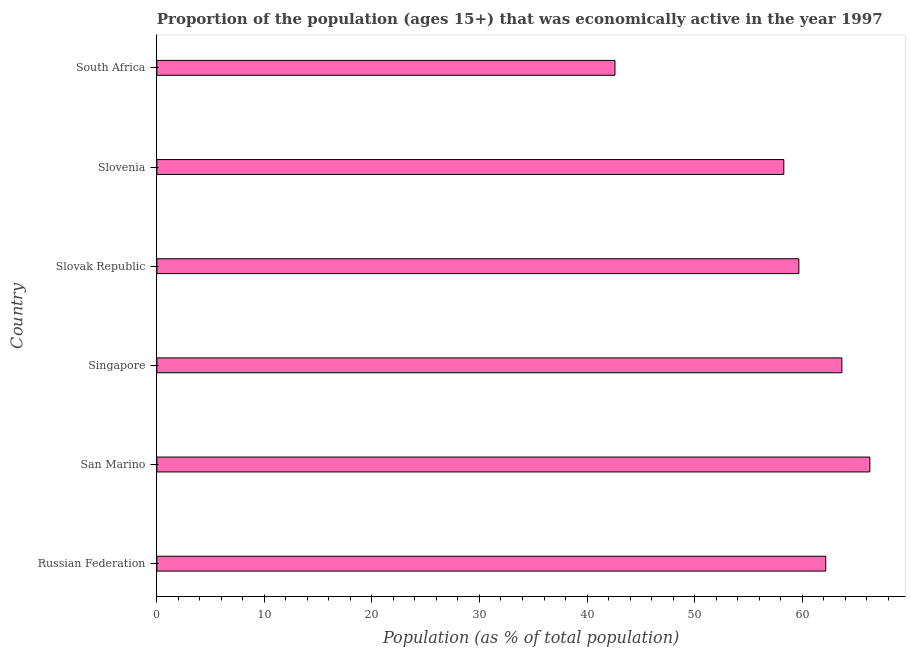What is the title of the graph?
Give a very brief answer. Proportion of the population (ages 15+) that was economically active in the year 1997. What is the label or title of the X-axis?
Keep it short and to the point. Population (as % of total population). What is the label or title of the Y-axis?
Offer a very short reply. Country. What is the percentage of economically active population in Singapore?
Your answer should be compact. 63.7. Across all countries, what is the maximum percentage of economically active population?
Give a very brief answer. 66.3. Across all countries, what is the minimum percentage of economically active population?
Give a very brief answer. 42.6. In which country was the percentage of economically active population maximum?
Provide a succinct answer. San Marino. In which country was the percentage of economically active population minimum?
Your answer should be compact. South Africa. What is the sum of the percentage of economically active population?
Ensure brevity in your answer.  352.8. What is the difference between the percentage of economically active population in Singapore and Slovak Republic?
Provide a short and direct response. 4. What is the average percentage of economically active population per country?
Offer a terse response. 58.8. What is the median percentage of economically active population?
Provide a succinct answer. 60.95. In how many countries, is the percentage of economically active population greater than 54 %?
Provide a succinct answer. 5. What is the ratio of the percentage of economically active population in Russian Federation to that in South Africa?
Ensure brevity in your answer.  1.46. What is the difference between the highest and the second highest percentage of economically active population?
Offer a terse response. 2.6. Is the sum of the percentage of economically active population in Slovak Republic and Slovenia greater than the maximum percentage of economically active population across all countries?
Make the answer very short. Yes. What is the difference between the highest and the lowest percentage of economically active population?
Offer a very short reply. 23.7. In how many countries, is the percentage of economically active population greater than the average percentage of economically active population taken over all countries?
Your response must be concise. 4. How many bars are there?
Offer a very short reply. 6. How many countries are there in the graph?
Give a very brief answer. 6. What is the difference between two consecutive major ticks on the X-axis?
Ensure brevity in your answer.  10. What is the Population (as % of total population) in Russian Federation?
Provide a succinct answer. 62.2. What is the Population (as % of total population) of San Marino?
Make the answer very short. 66.3. What is the Population (as % of total population) of Singapore?
Your answer should be very brief. 63.7. What is the Population (as % of total population) of Slovak Republic?
Provide a succinct answer. 59.7. What is the Population (as % of total population) of Slovenia?
Provide a short and direct response. 58.3. What is the Population (as % of total population) of South Africa?
Your answer should be compact. 42.6. What is the difference between the Population (as % of total population) in Russian Federation and San Marino?
Provide a succinct answer. -4.1. What is the difference between the Population (as % of total population) in Russian Federation and Singapore?
Provide a succinct answer. -1.5. What is the difference between the Population (as % of total population) in Russian Federation and Slovenia?
Offer a very short reply. 3.9. What is the difference between the Population (as % of total population) in Russian Federation and South Africa?
Keep it short and to the point. 19.6. What is the difference between the Population (as % of total population) in San Marino and Singapore?
Offer a very short reply. 2.6. What is the difference between the Population (as % of total population) in San Marino and Slovenia?
Ensure brevity in your answer.  8. What is the difference between the Population (as % of total population) in San Marino and South Africa?
Keep it short and to the point. 23.7. What is the difference between the Population (as % of total population) in Singapore and Slovak Republic?
Your answer should be compact. 4. What is the difference between the Population (as % of total population) in Singapore and South Africa?
Your response must be concise. 21.1. What is the difference between the Population (as % of total population) in Slovenia and South Africa?
Provide a succinct answer. 15.7. What is the ratio of the Population (as % of total population) in Russian Federation to that in San Marino?
Offer a very short reply. 0.94. What is the ratio of the Population (as % of total population) in Russian Federation to that in Singapore?
Provide a succinct answer. 0.98. What is the ratio of the Population (as % of total population) in Russian Federation to that in Slovak Republic?
Make the answer very short. 1.04. What is the ratio of the Population (as % of total population) in Russian Federation to that in Slovenia?
Provide a short and direct response. 1.07. What is the ratio of the Population (as % of total population) in Russian Federation to that in South Africa?
Ensure brevity in your answer.  1.46. What is the ratio of the Population (as % of total population) in San Marino to that in Singapore?
Your response must be concise. 1.04. What is the ratio of the Population (as % of total population) in San Marino to that in Slovak Republic?
Ensure brevity in your answer.  1.11. What is the ratio of the Population (as % of total population) in San Marino to that in Slovenia?
Make the answer very short. 1.14. What is the ratio of the Population (as % of total population) in San Marino to that in South Africa?
Ensure brevity in your answer.  1.56. What is the ratio of the Population (as % of total population) in Singapore to that in Slovak Republic?
Keep it short and to the point. 1.07. What is the ratio of the Population (as % of total population) in Singapore to that in Slovenia?
Offer a terse response. 1.09. What is the ratio of the Population (as % of total population) in Singapore to that in South Africa?
Offer a very short reply. 1.5. What is the ratio of the Population (as % of total population) in Slovak Republic to that in Slovenia?
Keep it short and to the point. 1.02. What is the ratio of the Population (as % of total population) in Slovak Republic to that in South Africa?
Your answer should be very brief. 1.4. What is the ratio of the Population (as % of total population) in Slovenia to that in South Africa?
Ensure brevity in your answer.  1.37. 